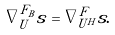Convert formula to latex. <formula><loc_0><loc_0><loc_500><loc_500>\nabla ^ { F _ { B } } _ { U } s = \nabla ^ { F } _ { U ^ { H } } s .</formula> 